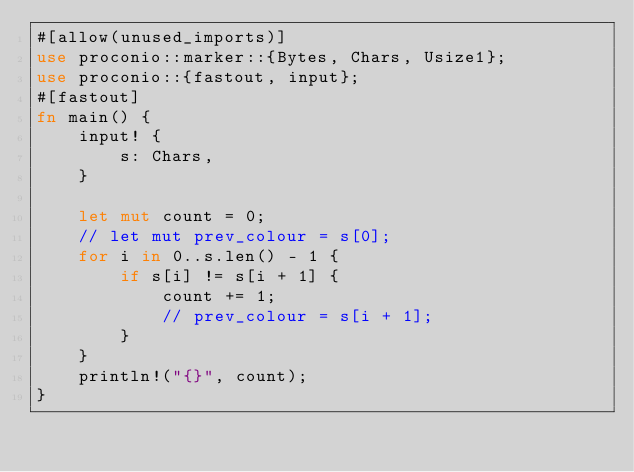<code> <loc_0><loc_0><loc_500><loc_500><_Rust_>#[allow(unused_imports)]
use proconio::marker::{Bytes, Chars, Usize1};
use proconio::{fastout, input};
#[fastout]
fn main() {
    input! {
        s: Chars,
    }

    let mut count = 0;
    // let mut prev_colour = s[0];
    for i in 0..s.len() - 1 {
        if s[i] != s[i + 1] {
            count += 1;
            // prev_colour = s[i + 1];
        }
    }
    println!("{}", count);
}
</code> 